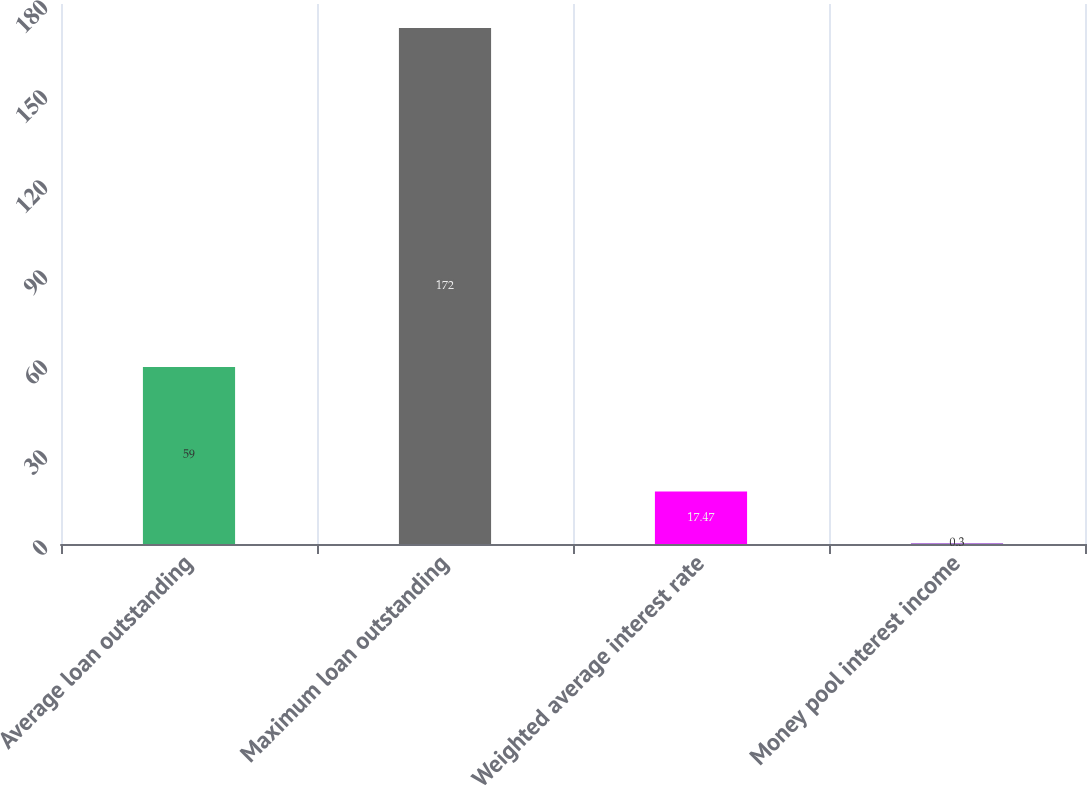Convert chart. <chart><loc_0><loc_0><loc_500><loc_500><bar_chart><fcel>Average loan outstanding<fcel>Maximum loan outstanding<fcel>Weighted average interest rate<fcel>Money pool interest income<nl><fcel>59<fcel>172<fcel>17.47<fcel>0.3<nl></chart> 